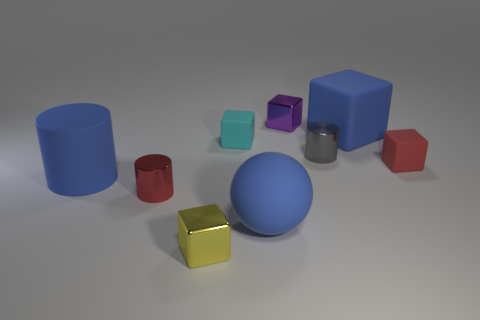Are there an equal number of small red things that are right of the yellow thing and tiny matte blocks in front of the cyan object?
Your answer should be compact. Yes. How many blue objects have the same shape as the yellow object?
Ensure brevity in your answer.  1. Are any yellow metallic cylinders visible?
Give a very brief answer. No. Does the large ball have the same material as the cylinder that is behind the small red cube?
Ensure brevity in your answer.  No. What material is the yellow block that is the same size as the cyan matte thing?
Make the answer very short. Metal. Is there another red cylinder that has the same material as the red cylinder?
Your response must be concise. No. Is there a gray object that is in front of the red thing on the left side of the shiny cube in front of the purple thing?
Your answer should be very brief. No. What is the shape of the red metal thing that is the same size as the gray metallic thing?
Your answer should be compact. Cylinder. There is a metal block that is left of the cyan rubber cube; is its size the same as the metal block behind the tiny yellow thing?
Make the answer very short. Yes. How many blocks are there?
Your response must be concise. 5. 